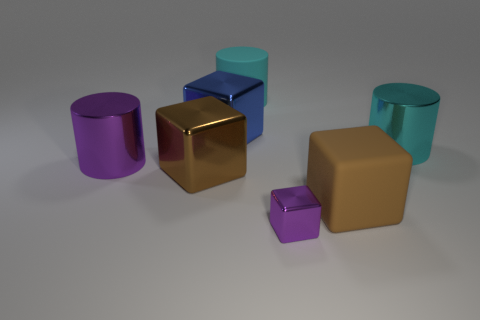Does the blue thing have the same size as the brown block to the left of the small purple cube?
Offer a very short reply. Yes. There is a matte thing that is behind the large cyan metallic cylinder; what is its shape?
Give a very brief answer. Cylinder. Is there anything else that is the same material as the purple cylinder?
Give a very brief answer. Yes. Are there more tiny objects right of the small purple shiny thing than big blue cubes?
Offer a very short reply. No. How many large brown matte objects are in front of the big metal cylinder on the left side of the matte thing that is behind the big purple object?
Make the answer very short. 1. There is a object behind the blue metal object; does it have the same size as the metallic cylinder to the left of the tiny shiny object?
Make the answer very short. Yes. There is a big cyan cylinder left of the large cyan object to the right of the large matte block; what is its material?
Keep it short and to the point. Rubber. How many objects are either purple objects on the right side of the cyan matte object or tiny red blocks?
Your answer should be compact. 1. Are there an equal number of big blocks in front of the large purple metallic thing and large purple metallic cylinders that are on the left side of the large cyan metal object?
Keep it short and to the point. No. There is a brown thing on the left side of the tiny object on the left side of the brown block on the right side of the small purple metal cube; what is its material?
Keep it short and to the point. Metal. 